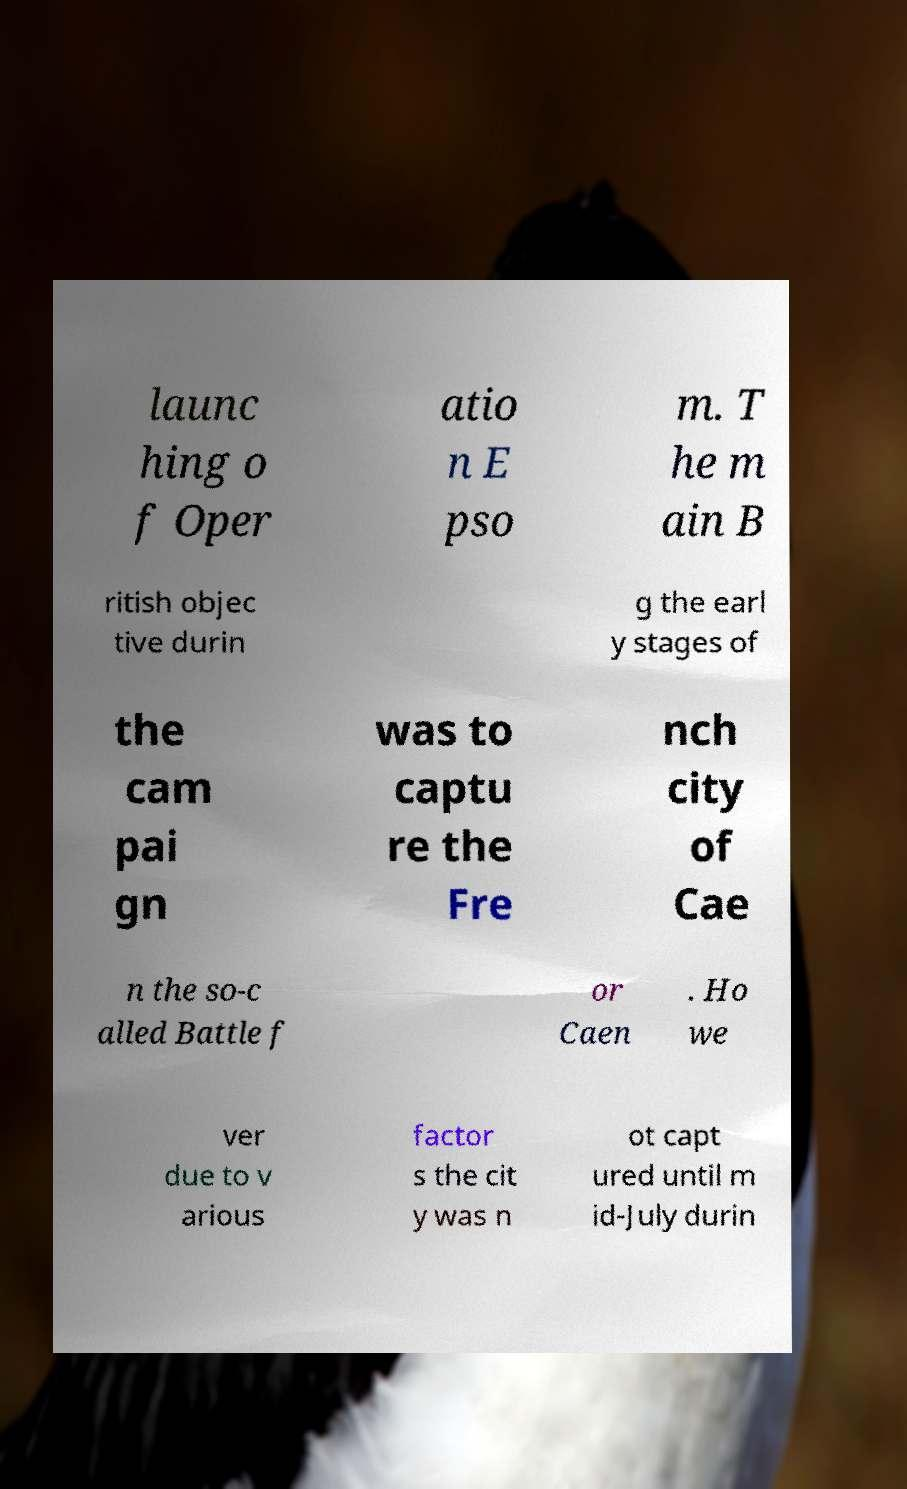There's text embedded in this image that I need extracted. Can you transcribe it verbatim? launc hing o f Oper atio n E pso m. T he m ain B ritish objec tive durin g the earl y stages of the cam pai gn was to captu re the Fre nch city of Cae n the so-c alled Battle f or Caen . Ho we ver due to v arious factor s the cit y was n ot capt ured until m id-July durin 